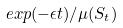<formula> <loc_0><loc_0><loc_500><loc_500>e x p ( - \epsilon t ) / \mu ( S _ { t } )</formula> 